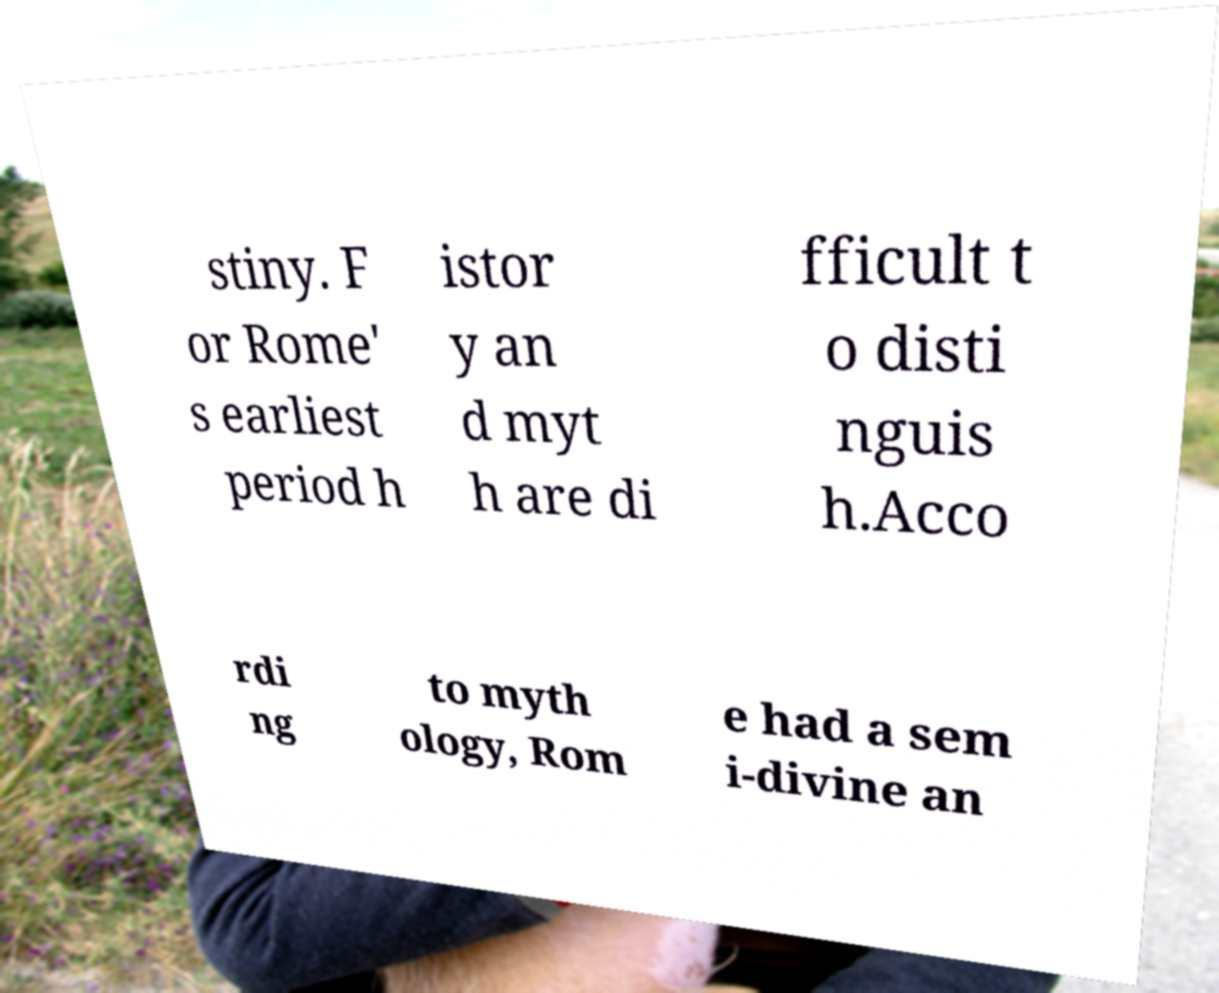Could you assist in decoding the text presented in this image and type it out clearly? stiny. F or Rome' s earliest period h istor y an d myt h are di fficult t o disti nguis h.Acco rdi ng to myth ology, Rom e had a sem i-divine an 